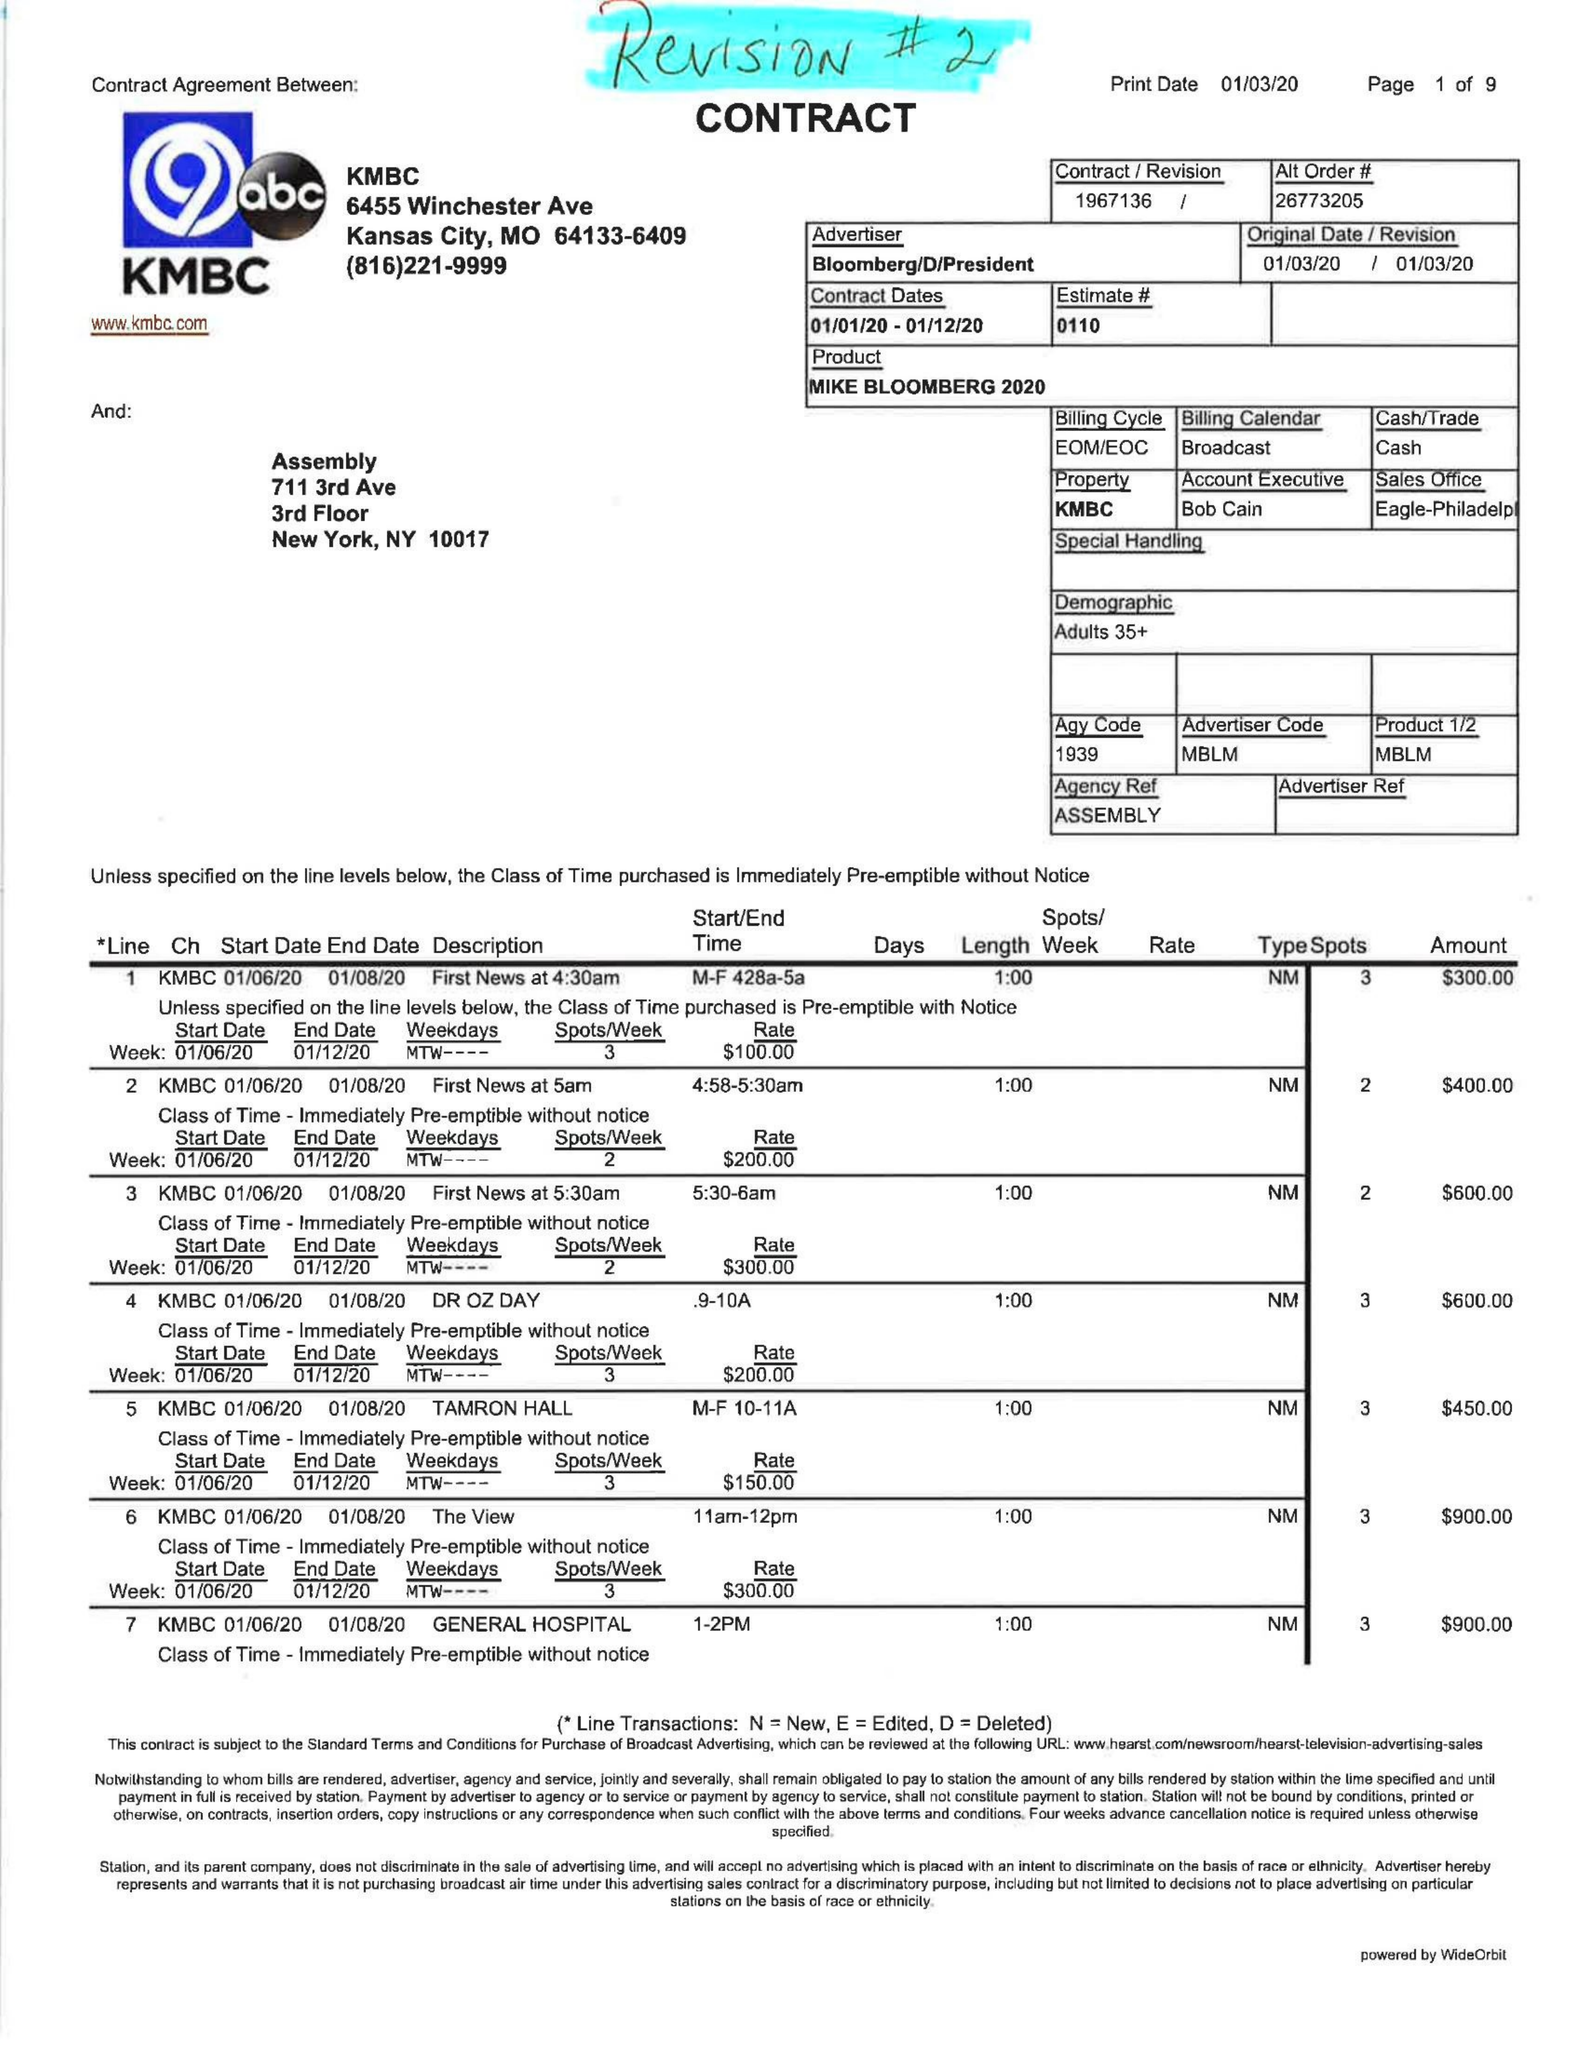What is the value for the flight_from?
Answer the question using a single word or phrase. 01/01/20 